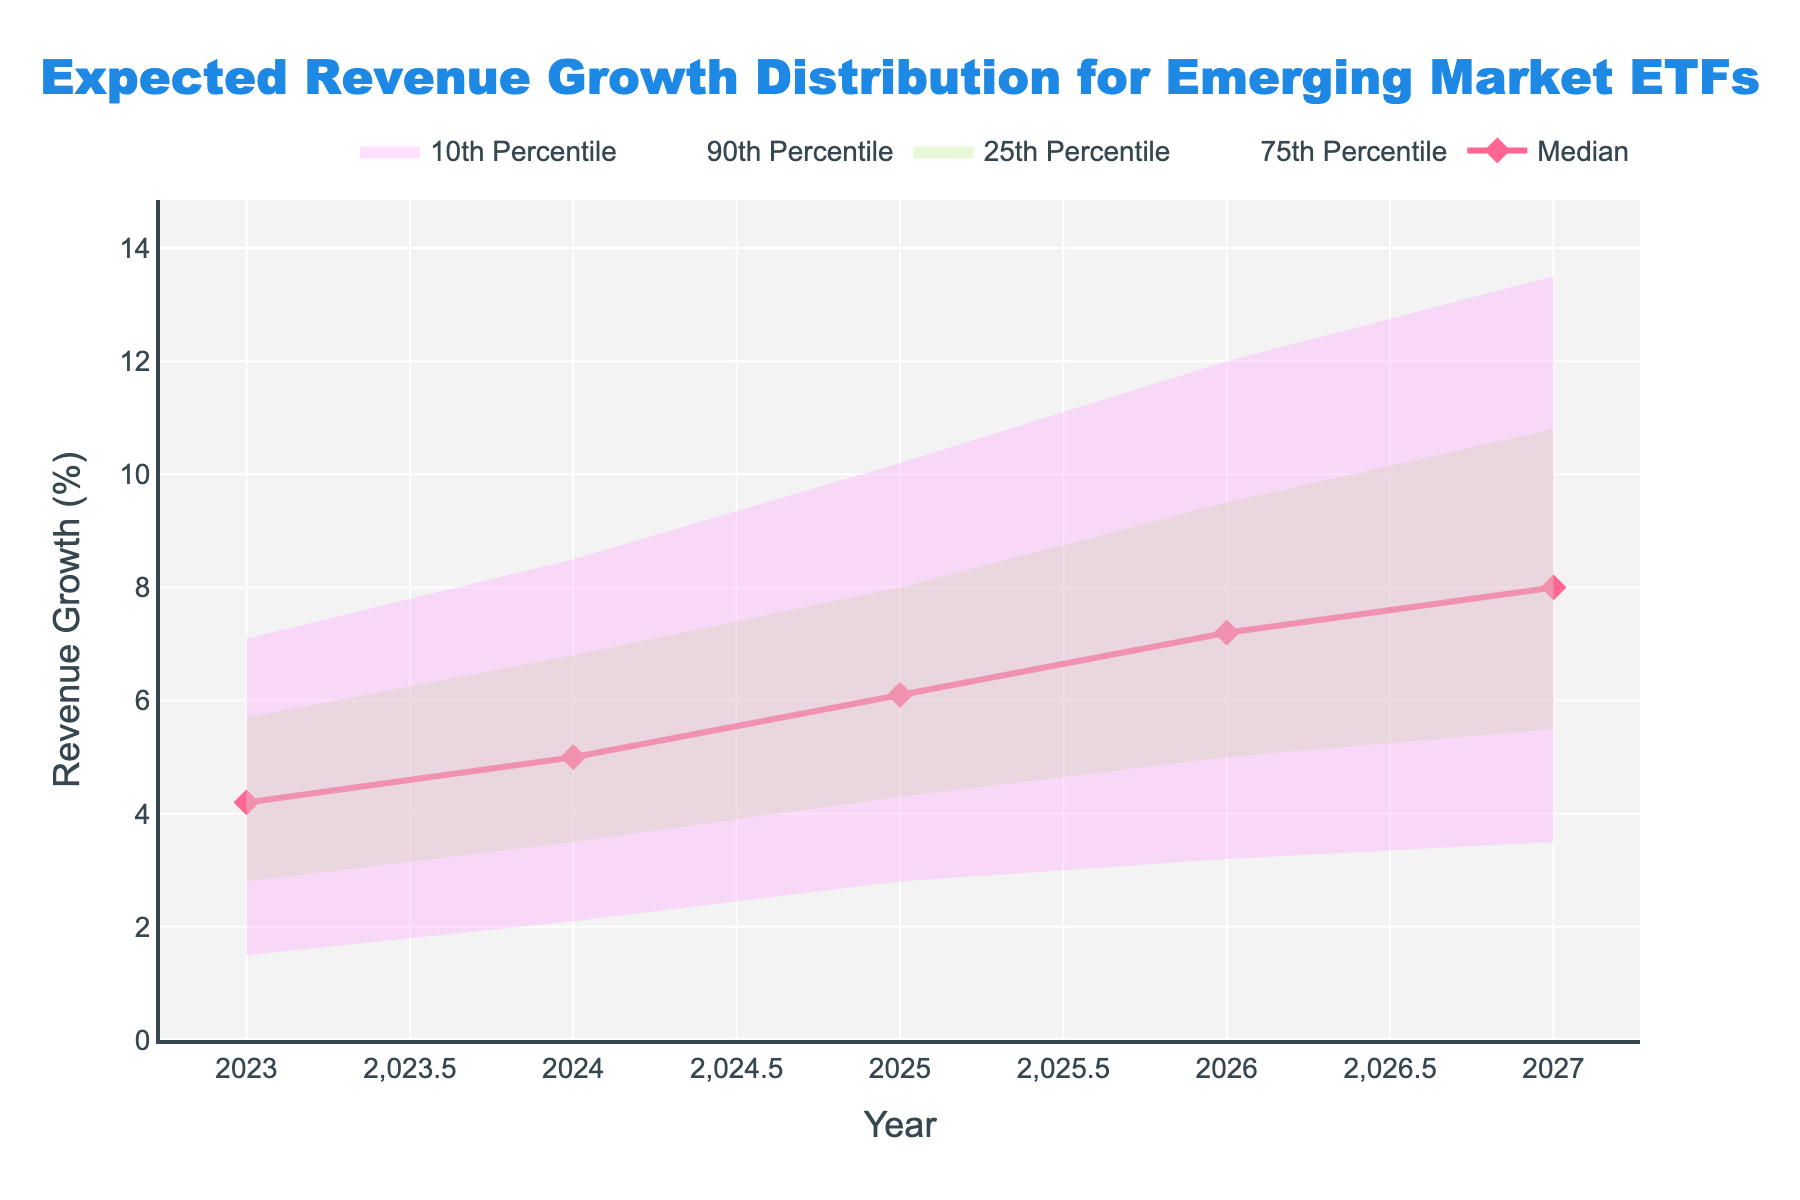What is the title of the figure? The title is typically found at the top of the chart, providing a summary of the figure's content. In this case, the title reads 'Expected Revenue Growth Distribution for Emerging Market ETFs'.
Answer: Expected Revenue Growth Distribution for Emerging Market ETFs What is the median revenue growth for the year 2025? Locate the median line in the figure and find its value for the year 2025 on the x-axis. The graph shows this value at the intersection with the y-axis for 2025.
Answer: 6.1% What is the range between the 10th and 90th percentile for the year 2026? For 2026, identify the values of the 10th percentile and the 90th percentile from the figure. Subtract the 10th percentile value from the 90th percentile value to get the range.
Answer: 8.8% How does the 75th percentile in 2024 compare to the 25th percentile in 2027? Find the values of the 75th percentile for 2024 and the 25th percentile for 2027. Compare these two y-values to determine their relationship.
Answer: The 75th percentile in 2024 (6.8%) is greater than the 25th percentile in 2027 (5.5%) By how much is the median revenue growth projected to increase from 2023 to 2027? Determine the median values for 2023 and 2027 from the figure. Subtract the 2023 median value from the 2027 median value to find the increase.
Answer: 3.8% What is the overall trend observed in the median revenue growth from 2023 to 2027? The median line in the figure indicates the trend over the years. Observing the slope of this line from 2023 to 2027 reveals whether it is increasing, decreasing, or stable.
Answer: Increasing What year shows the highest expected revenue growth at the 90th percentile? Examine the 90th percentile line across all years shown in the figure. Identify the year corresponding to the highest y-value on this line.
Answer: 2027 Which year has the smallest range between the 25th and 75th percentile? Calculate the interquartile range (difference between the 75th and 25th percentiles) for each year presented. Compare these ranges to determine the smallest.
Answer: 2023 What percentile has the highest projected revenue growth in 2026? Among the 10th, 25th, median, 75th, and 90th percentiles, identify which one has the highest y-value for the year 2026.
Answer: 90th percentile Is the 10th percentile for 2025 greater or less than the median for 2023? Compare the values given in the 10th percentile for 2025 and the median for 2023 from the figure. Determine whether the 2025 value is higher or lower than the 2023 value.
Answer: Greater 